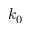Convert formula to latex. <formula><loc_0><loc_0><loc_500><loc_500>k _ { 0 }</formula> 